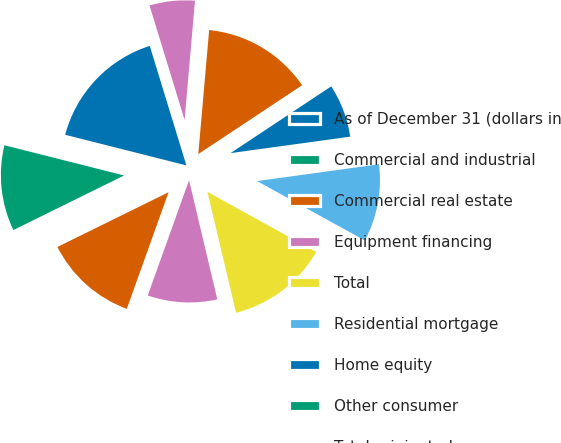Convert chart to OTSL. <chart><loc_0><loc_0><loc_500><loc_500><pie_chart><fcel>As of December 31 (dollars in<fcel>Commercial and industrial<fcel>Commercial real estate<fcel>Equipment financing<fcel>Total<fcel>Residential mortgage<fcel>Home equity<fcel>Other consumer<fcel>Total originated<fcel>Residential<nl><fcel>16.33%<fcel>11.22%<fcel>12.24%<fcel>9.18%<fcel>13.27%<fcel>10.2%<fcel>7.14%<fcel>0.0%<fcel>14.29%<fcel>6.12%<nl></chart> 